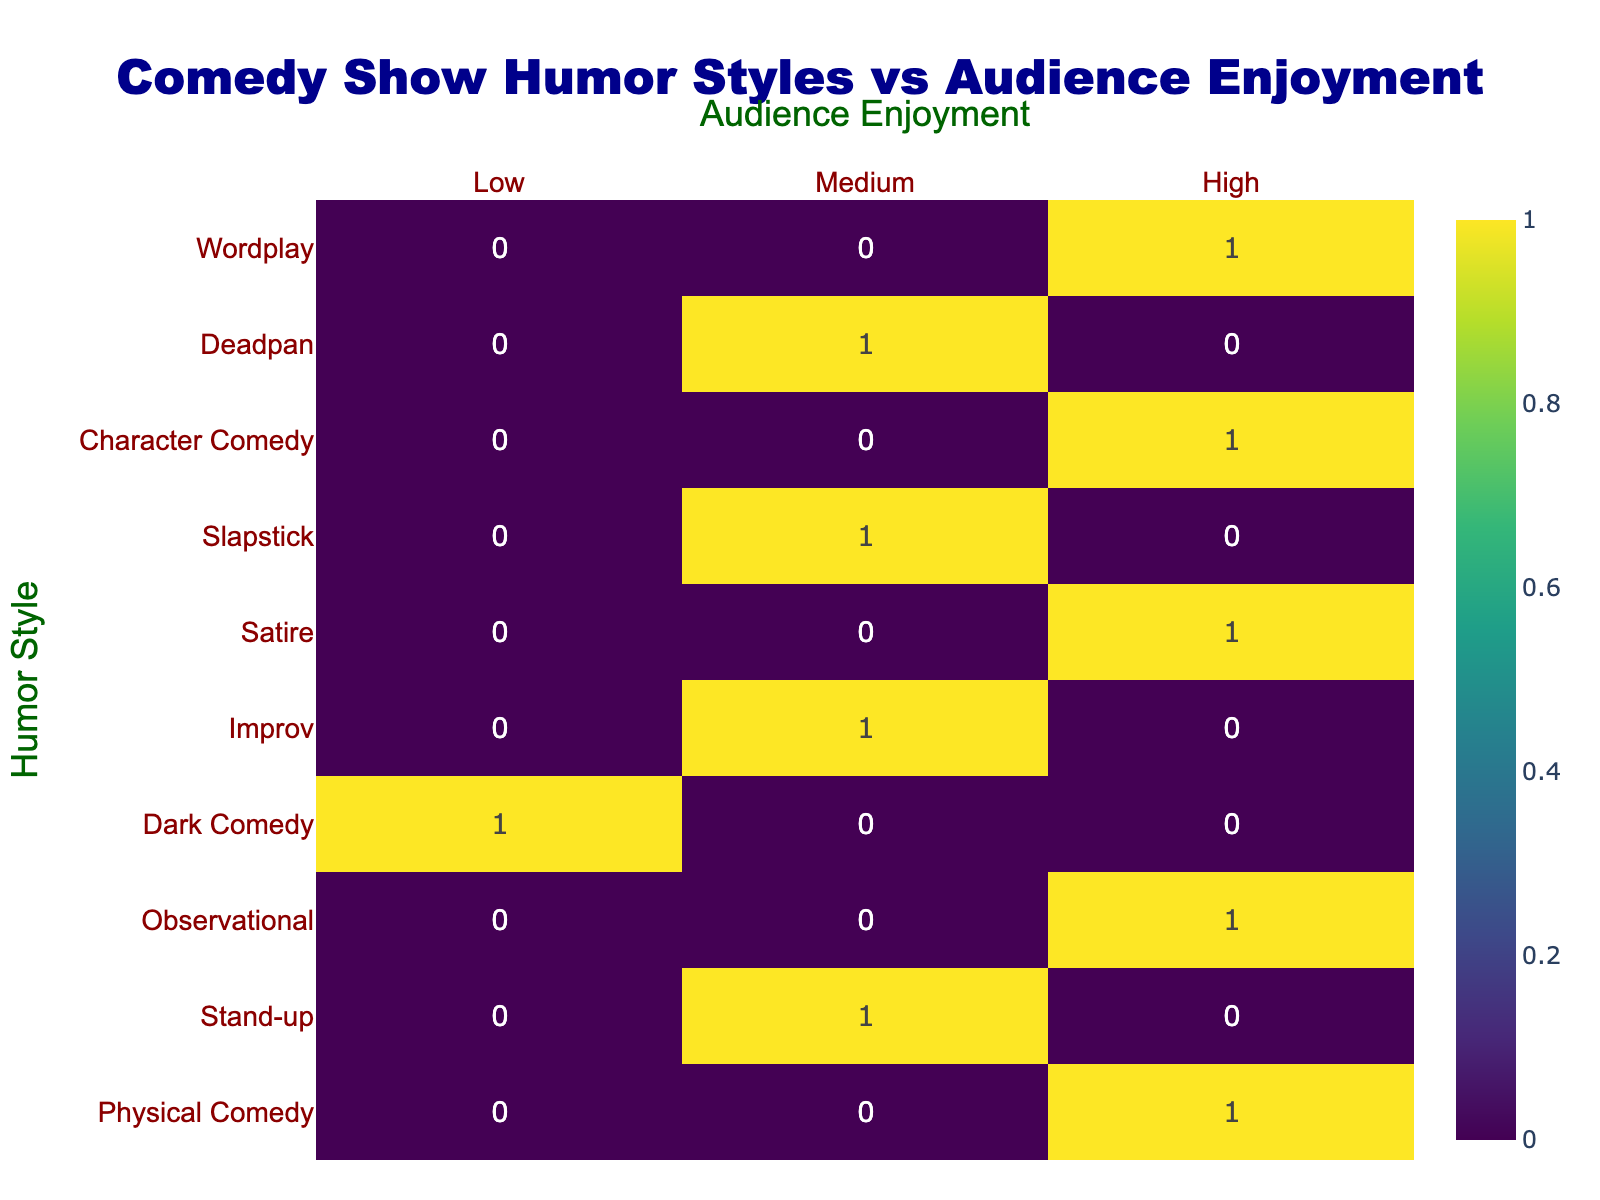What humor style had the highest audience enjoyment? The humor style with the highest audience enjoyment listed in the table is Physical Comedy, Observational, Satire, Character Comedy, and Wordplay, all marked as High.
Answer: Physical Comedy, Observational, Satire, Character Comedy, Wordplay Which show had a medium level of audience enjoyment in the improv category? The only show categorized as Improv with a medium level of audience enjoyment is "Whose Line Is It Anyway?".
Answer: Whose Line Is It Anyway? How many shows had low audience enjoyment? In the table, there is a single show with low audience enjoyment, which is "Sam Kinison: Live".
Answer: 1 What is the difference in the number of shows rated high and low for audience enjoyment? There are 5 shows rated as high and 1 show rated as low. The difference is 5 - 1 = 4.
Answer: 4 Did any shows rated medium for audience enjoyment exceed two in number? Yes, there are 3 shows that are rated medium for audience enjoyment: "Ali Wong: Baby Cobra", "Improv" and "Jim Carrey: Unnatural Act".
Answer: Yes What is the total number of shows listed in the table that received high enjoyment ratings? There are 5 shows categorized with high audience enjoyment: "Kevin Hart: Irresponsible", "Jerry Seinfeld: 23 Hours to Kill", "John Oliver's Last Week Tonight", "Tina Fey: The Truth About Santa", and "George Carlin: Questions and Answers".
Answer: 5 Which humor style corresponds to the only show with a low enjoyment rating? The humor style that corresponds to the only show with low enjoyment, which is marked as "Sam Kinison: Live", is Dark Comedy.
Answer: Dark Comedy How many shows rated medium are there among all provided humor styles? There are 3 shows that received a medium rating: "Ali Wong: Baby Cobra", "Improv", and "Jim Carrey: Unnatural Act".
Answer: 3 What proportion of humor styles resulted in high audience enjoyment? There are 5 humor styles that have high audience enjoyment (Physical Comedy, Observational, Satire, Character Comedy, Wordplay) out of 10 total styles listed. Hence the proportion is 5/10 = 0.5 or 50%.
Answer: 50% 